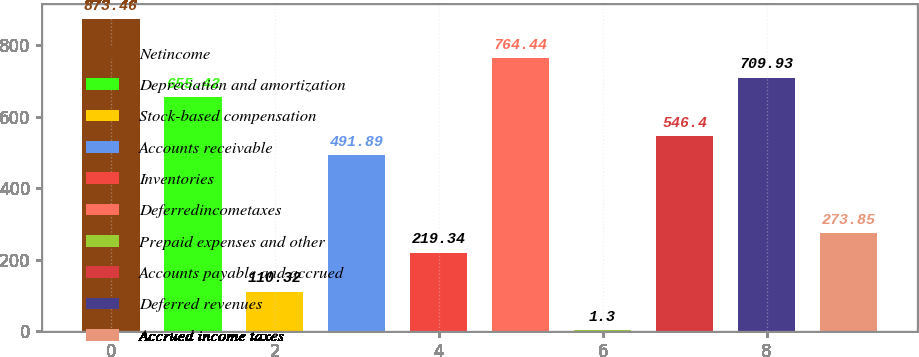<chart> <loc_0><loc_0><loc_500><loc_500><bar_chart><fcel>Netincome<fcel>Depreciation and amortization<fcel>Stock-based compensation<fcel>Accounts receivable<fcel>Inventories<fcel>Deferredincometaxes<fcel>Prepaid expenses and other<fcel>Accounts payable and accrued<fcel>Deferred revenues<fcel>Accrued income taxes<nl><fcel>873.46<fcel>655.42<fcel>110.32<fcel>491.89<fcel>219.34<fcel>764.44<fcel>1.3<fcel>546.4<fcel>709.93<fcel>273.85<nl></chart> 